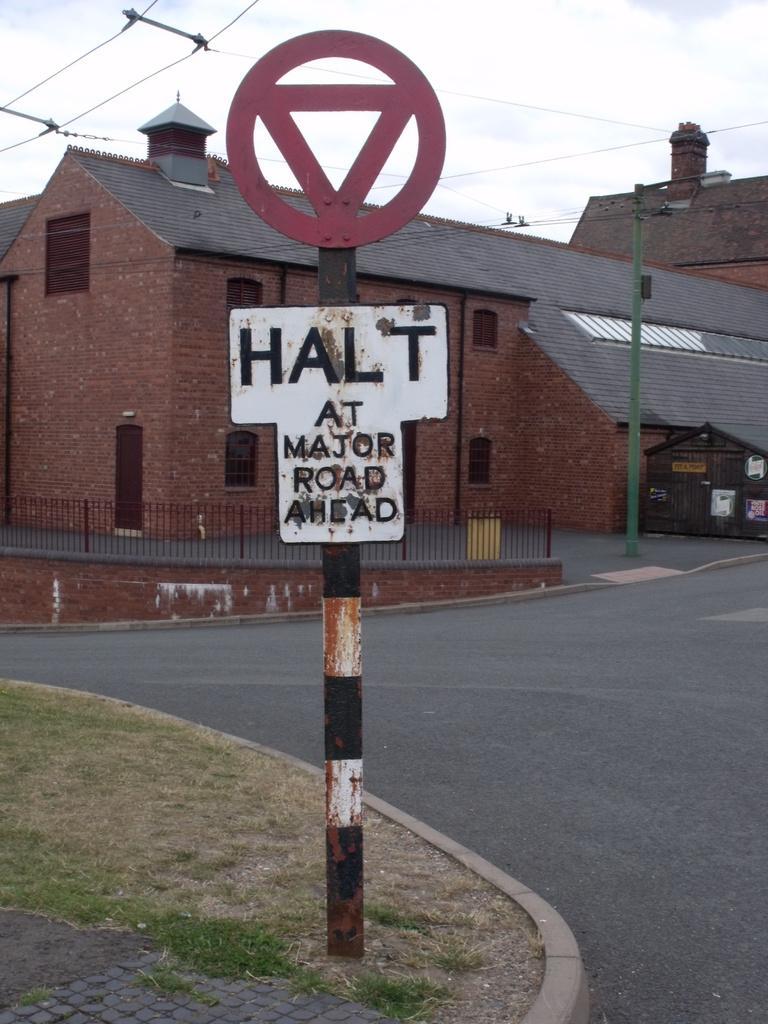Please provide a concise description of this image. In the image there is a sign board in the middle of the picture and behind it there are buildings with street pole in front of it followed by a fence behind it and above its sky. there is road in front of the building. 